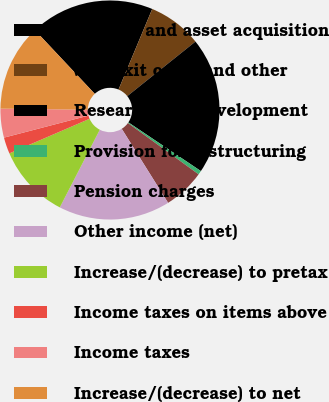<chart> <loc_0><loc_0><loc_500><loc_500><pie_chart><fcel>License and asset acquisition<fcel>Site exit costs and other<fcel>Research and development<fcel>Provision for restructuring<fcel>Pension charges<fcel>Other income (net)<fcel>Increase/(decrease) to pretax<fcel>Income taxes on items above<fcel>Income taxes<fcel>Increase/(decrease) to net<nl><fcel>18.31%<fcel>7.95%<fcel>20.15%<fcel>0.58%<fcel>6.1%<fcel>16.47%<fcel>10.95%<fcel>2.42%<fcel>4.26%<fcel>12.79%<nl></chart> 